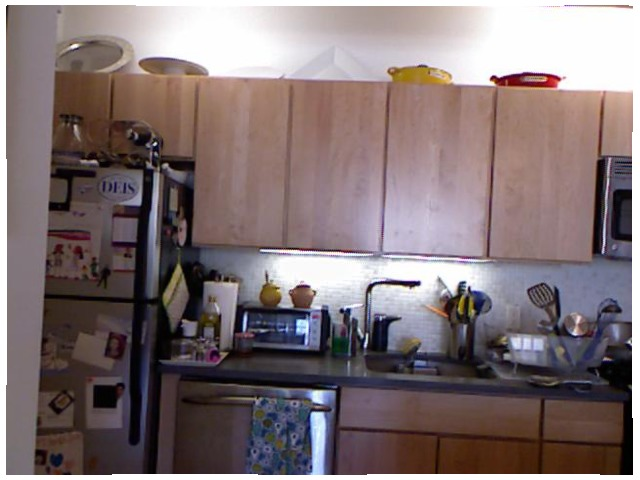<image>
Is there a vessel under the cloth? No. The vessel is not positioned under the cloth. The vertical relationship between these objects is different. Is the kitchen towel to the right of the oil? Yes. From this viewpoint, the kitchen towel is positioned to the right side relative to the oil. 